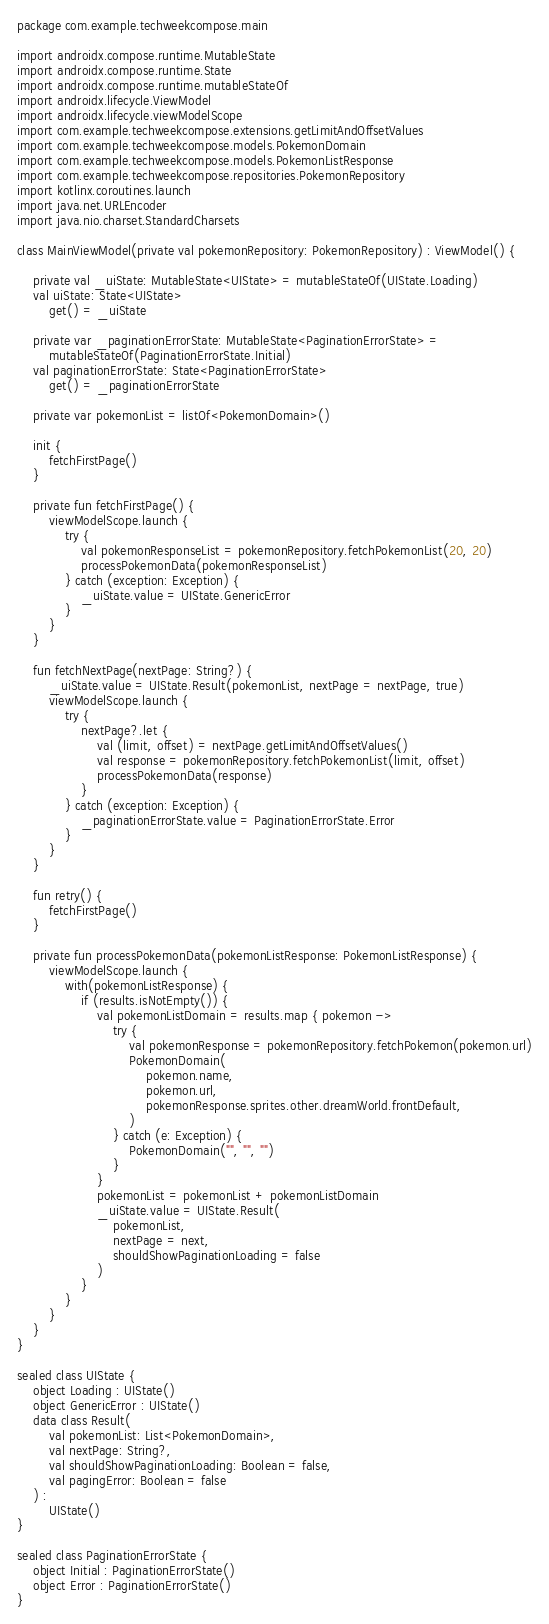<code> <loc_0><loc_0><loc_500><loc_500><_Kotlin_>package com.example.techweekcompose.main

import androidx.compose.runtime.MutableState
import androidx.compose.runtime.State
import androidx.compose.runtime.mutableStateOf
import androidx.lifecycle.ViewModel
import androidx.lifecycle.viewModelScope
import com.example.techweekcompose.extensions.getLimitAndOffsetValues
import com.example.techweekcompose.models.PokemonDomain
import com.example.techweekcompose.models.PokemonListResponse
import com.example.techweekcompose.repositories.PokemonRepository
import kotlinx.coroutines.launch
import java.net.URLEncoder
import java.nio.charset.StandardCharsets

class MainViewModel(private val pokemonRepository: PokemonRepository) : ViewModel() {

    private val _uiState: MutableState<UIState> = mutableStateOf(UIState.Loading)
    val uiState: State<UIState>
        get() = _uiState

    private var _paginationErrorState: MutableState<PaginationErrorState> =
        mutableStateOf(PaginationErrorState.Initial)
    val paginationErrorState: State<PaginationErrorState>
        get() = _paginationErrorState

    private var pokemonList = listOf<PokemonDomain>()

    init {
        fetchFirstPage()
    }

    private fun fetchFirstPage() {
        viewModelScope.launch {
            try {
                val pokemonResponseList = pokemonRepository.fetchPokemonList(20, 20)
                processPokemonData(pokemonResponseList)
            } catch (exception: Exception) {
                _uiState.value = UIState.GenericError
            }
        }
    }

    fun fetchNextPage(nextPage: String?) {
        _uiState.value = UIState.Result(pokemonList, nextPage = nextPage, true)
        viewModelScope.launch {
            try {
                nextPage?.let {
                    val (limit, offset) = nextPage.getLimitAndOffsetValues()
                    val response = pokemonRepository.fetchPokemonList(limit, offset)
                    processPokemonData(response)
                }
            } catch (exception: Exception) {
                _paginationErrorState.value = PaginationErrorState.Error
            }
        }
    }

    fun retry() {
        fetchFirstPage()
    }

    private fun processPokemonData(pokemonListResponse: PokemonListResponse) {
        viewModelScope.launch {
            with(pokemonListResponse) {
                if (results.isNotEmpty()) {
                    val pokemonListDomain = results.map { pokemon ->
                        try {
                            val pokemonResponse = pokemonRepository.fetchPokemon(pokemon.url)
                            PokemonDomain(
                                pokemon.name,
                                pokemon.url,
                                pokemonResponse.sprites.other.dreamWorld.frontDefault,
                            )
                        } catch (e: Exception) {
                            PokemonDomain("", "", "")
                        }
                    }
                    pokemonList = pokemonList + pokemonListDomain
                    _uiState.value = UIState.Result(
                        pokemonList,
                        nextPage = next,
                        shouldShowPaginationLoading = false
                    )
                }
            }
        }
    }
}

sealed class UIState {
    object Loading : UIState()
    object GenericError : UIState()
    data class Result(
        val pokemonList: List<PokemonDomain>,
        val nextPage: String?,
        val shouldShowPaginationLoading: Boolean = false,
        val pagingError: Boolean = false
    ) :
        UIState()
}

sealed class PaginationErrorState {
    object Initial : PaginationErrorState()
    object Error : PaginationErrorState()
}</code> 